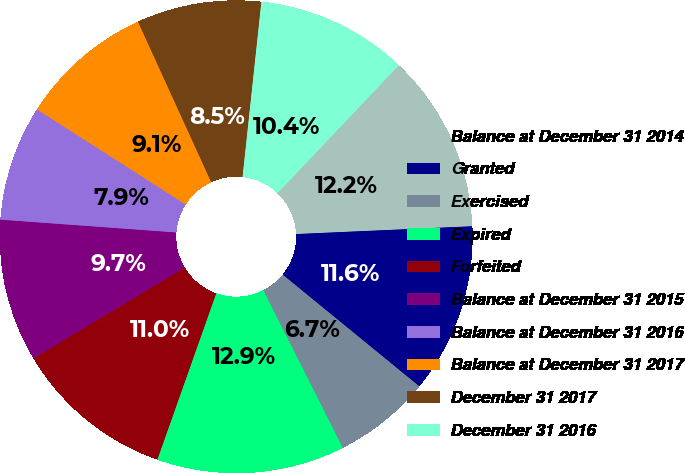Convert chart. <chart><loc_0><loc_0><loc_500><loc_500><pie_chart><fcel>Balance at December 31 2014<fcel>Granted<fcel>Exercised<fcel>Expired<fcel>Forfeited<fcel>Balance at December 31 2015<fcel>Balance at December 31 2016<fcel>Balance at December 31 2017<fcel>December 31 2017<fcel>December 31 2016<nl><fcel>12.22%<fcel>11.61%<fcel>6.66%<fcel>12.85%<fcel>10.99%<fcel>9.75%<fcel>7.9%<fcel>9.13%<fcel>8.52%<fcel>10.37%<nl></chart> 